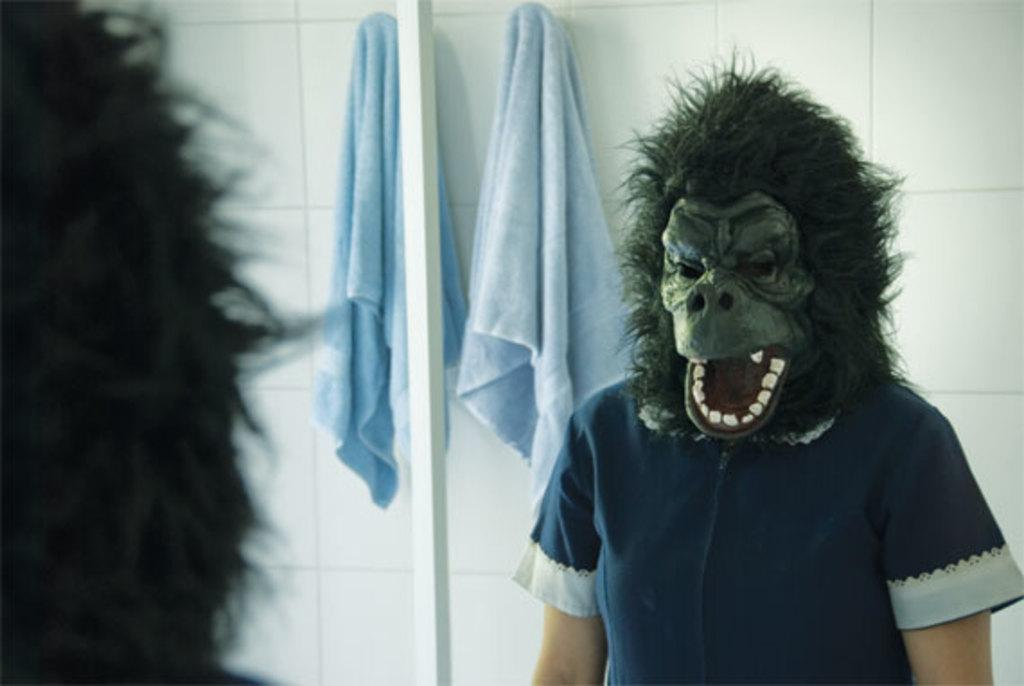What is the main subject of the image? There is a person in the image. What is the person wearing on their face? The person is wearing a chimpanzee mask. What object in the image allows the person to see their reflection? There is a mirror in the image. Can you describe the person's reflection in the mirror? The person's reflection is visible in the mirror. What is hanging on the wall in the image? There is a towel on the wall in the image. How many ducks are visible in the image? There are no ducks present in the image. What type of footwear is the person wearing in the image? The provided facts do not mention any footwear, so we cannot determine the type of footwear the person is wearing. 